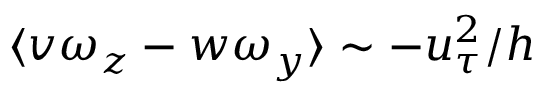Convert formula to latex. <formula><loc_0><loc_0><loc_500><loc_500>\langle v \omega _ { z } - w \omega _ { y } \rangle \sim - u _ { \tau } ^ { 2 } / h</formula> 